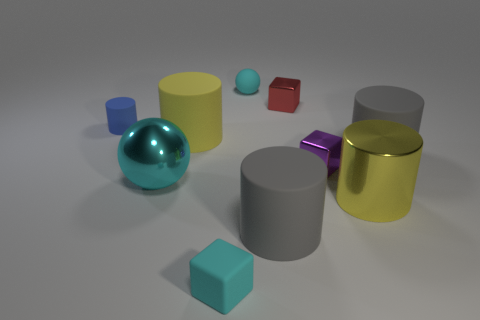Subtract all blue cylinders. How many cylinders are left? 4 Subtract all big yellow rubber cylinders. How many cylinders are left? 4 Subtract all red cylinders. Subtract all gray cubes. How many cylinders are left? 5 Subtract all cubes. How many objects are left? 7 Add 2 blue objects. How many blue objects are left? 3 Add 7 big yellow metal cylinders. How many big yellow metal cylinders exist? 8 Subtract 0 gray balls. How many objects are left? 10 Subtract all big blue shiny balls. Subtract all large shiny things. How many objects are left? 8 